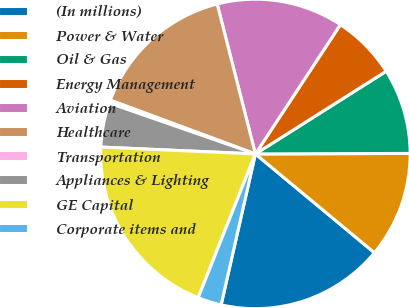Convert chart. <chart><loc_0><loc_0><loc_500><loc_500><pie_chart><fcel>(In millions)<fcel>Power & Water<fcel>Oil & Gas<fcel>Energy Management<fcel>Aviation<fcel>Healthcare<fcel>Transportation<fcel>Appliances & Lighting<fcel>GE Capital<fcel>Corporate items and<nl><fcel>17.53%<fcel>11.08%<fcel>8.92%<fcel>6.77%<fcel>13.23%<fcel>15.38%<fcel>0.32%<fcel>4.62%<fcel>19.68%<fcel>2.47%<nl></chart> 